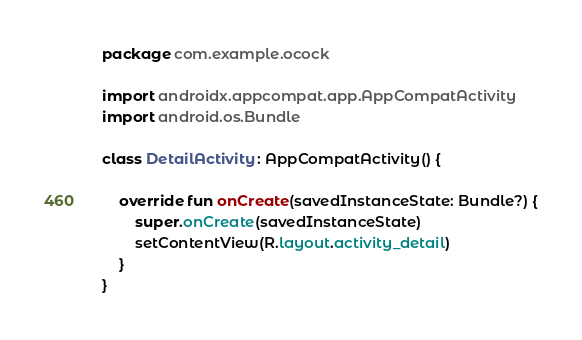Convert code to text. <code><loc_0><loc_0><loc_500><loc_500><_Kotlin_>package com.example.ocock

import androidx.appcompat.app.AppCompatActivity
import android.os.Bundle

class DetailActivity : AppCompatActivity() {

    override fun onCreate(savedInstanceState: Bundle?) {
        super.onCreate(savedInstanceState)
        setContentView(R.layout.activity_detail)
    }
}
</code> 